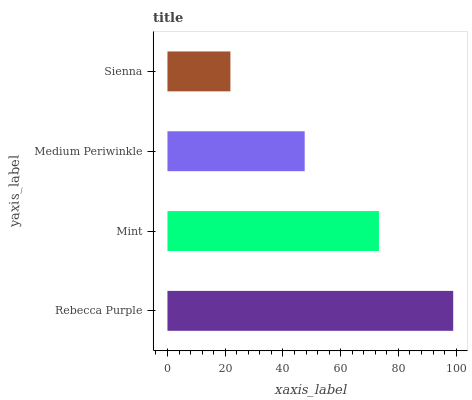Is Sienna the minimum?
Answer yes or no. Yes. Is Rebecca Purple the maximum?
Answer yes or no. Yes. Is Mint the minimum?
Answer yes or no. No. Is Mint the maximum?
Answer yes or no. No. Is Rebecca Purple greater than Mint?
Answer yes or no. Yes. Is Mint less than Rebecca Purple?
Answer yes or no. Yes. Is Mint greater than Rebecca Purple?
Answer yes or no. No. Is Rebecca Purple less than Mint?
Answer yes or no. No. Is Mint the high median?
Answer yes or no. Yes. Is Medium Periwinkle the low median?
Answer yes or no. Yes. Is Medium Periwinkle the high median?
Answer yes or no. No. Is Sienna the low median?
Answer yes or no. No. 